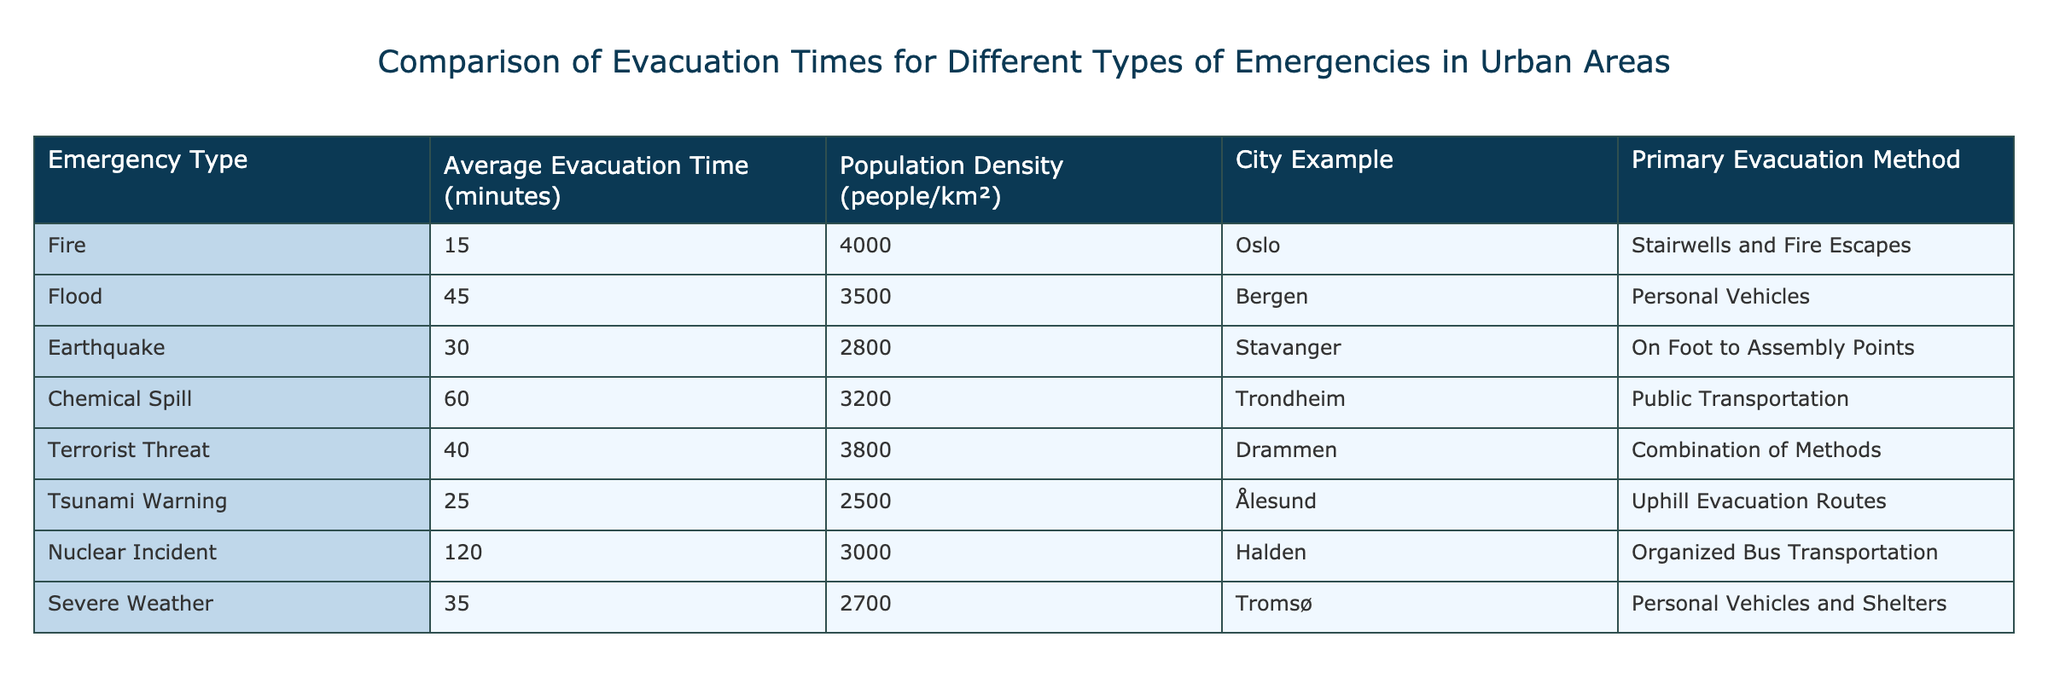What is the average evacuation time for a nuclear incident? The specific evacuation time for a nuclear incident is listed in the table as 120 minutes. Therefore, the average evacuation time for a nuclear incident is 120 minutes.
Answer: 120 minutes Which city has the longest average evacuation time? By looking at the evacuation times for each emergency type, the nuclear incident has the longest time at 120 minutes, which corresponds to the city of Halden.
Answer: Halden Is the average evacuation time for a tsunami warning more than 30 minutes? The table shows that the average evacuation time for a tsunami warning is 25 minutes, which is less than 30. Therefore, the answer is no.
Answer: No What is the combined average evacuation time for floods and severe weather? The average evacuation time for floods is 45 minutes, and for severe weather, it is 35 minutes. Their combined total is 45 + 35 = 80 minutes. To find the average, we divide by the number of emergencies (2), which gives us 80/2 = 40 minutes.
Answer: 40 minutes Which emergency type has a higher evacuation time, a terrorist threat or an earthquake? The evacuation time for a terrorist threat is 40 minutes, while for an earthquake, it is 30 minutes. Since 40 minutes is greater than 30 minutes, the terrorist threat has a higher evacuation time.
Answer: Terrorist Threat What is the average population density for emergency types with evacuation times greater than 40 minutes? The relevant emergencies with evacuation times greater than 40 minutes are a chemical spill (60 minutes) and a nuclear incident (120 minutes). Their population densities are 3200 and 3000 respectively. The average is calculated as (3200 + 3000) / 2 = 3100 people/km².
Answer: 3100 people/km² Are personal vehicles used as a primary evacuation method for more than one type of emergency? The table indicates that personal vehicles are the primary method for floods and severe weather. Therefore, since they appear for two types of emergencies, the answer is yes.
Answer: Yes Which type of emergency has the shortest evacuation time, and how does it compare to that of a chemical spill? The emergency with the shortest evacuation time is a fire at 15 minutes. The chemical spill has an evacuation time of 60 minutes. To compare, 15 minutes is lesser than 60 minutes.
Answer: Fire; 15 minutes is lesser than chemical spill (60 minutes) 